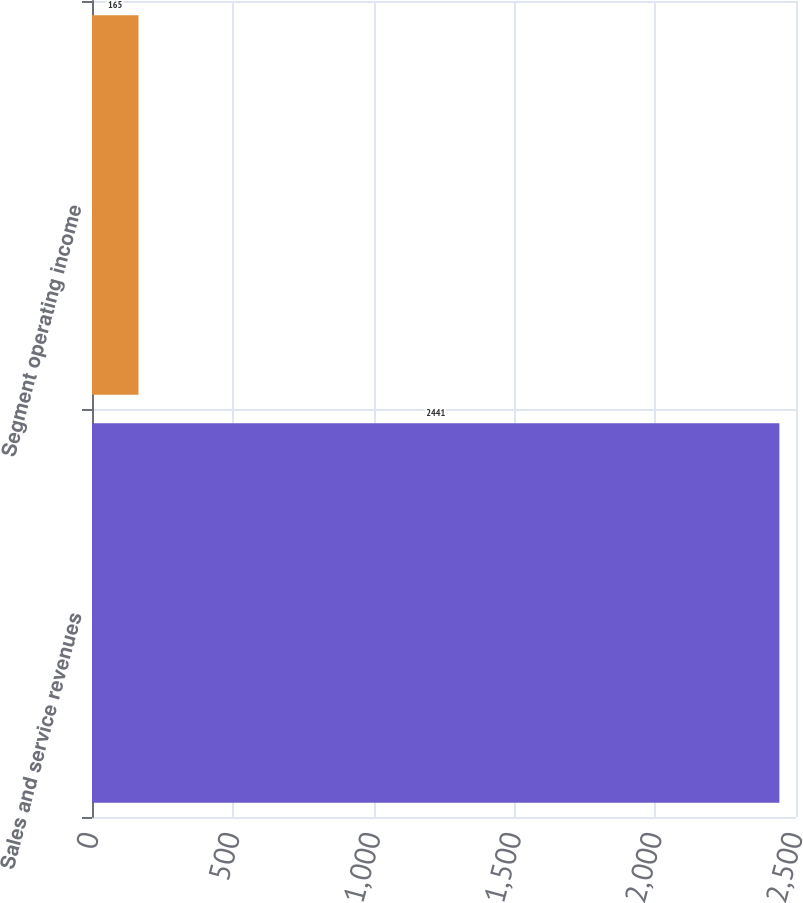Convert chart. <chart><loc_0><loc_0><loc_500><loc_500><bar_chart><fcel>Sales and service revenues<fcel>Segment operating income<nl><fcel>2441<fcel>165<nl></chart> 